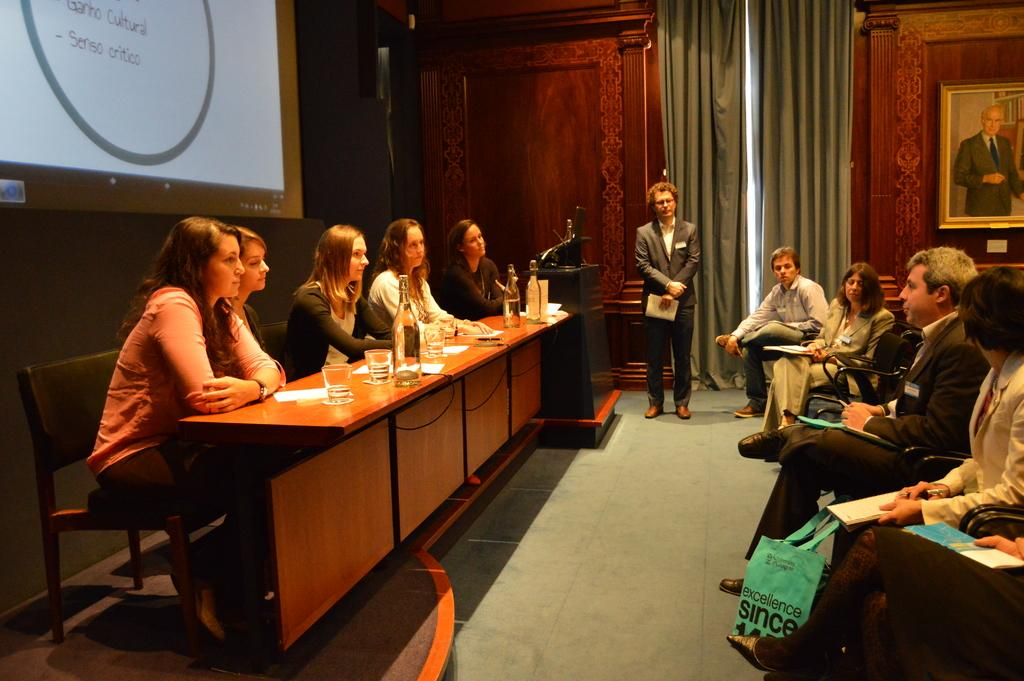What is the main activity of the people in the image? The main activity of the people in the image is sitting in chairs. What object is in front of the sitting people? There is a table in front of the sitting people. Can you describe the position of the person standing near the sitting people? A person is standing near the sitting people. What type of blood is visible on the wing of the bird in the image? There is no bird or blood present in the image; it only features people sitting in chairs and a person standing nearby. 